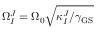Convert formula to latex. <formula><loc_0><loc_0><loc_500><loc_500>\Omega _ { I } ^ { J } = \Omega _ { 0 } \sqrt { \kappa _ { I } ^ { J } / \gamma _ { G S } }</formula> 